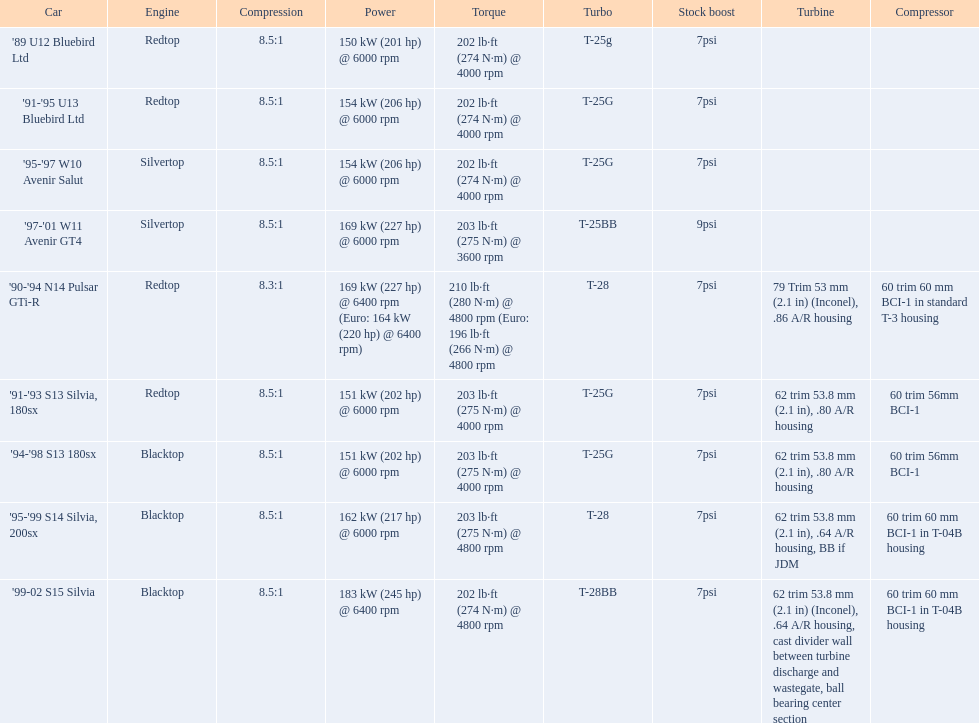What vehicles exist? '89 U12 Bluebird Ltd, 7psi, '91-'95 U13 Bluebird Ltd, 7psi, '95-'97 W10 Avenir Salut, 7psi, '97-'01 W11 Avenir GT4, 9psi, '90-'94 N14 Pulsar GTi-R, 7psi, '91-'93 S13 Silvia, 180sx, 7psi, '94-'98 S13 180sx, 7psi, '95-'99 S14 Silvia, 200sx, 7psi, '99-02 S15 Silvia, 7psi. Which standard boost surpasses 7psi? '97-'01 W11 Avenir GT4, 9psi. What automobile is it? '97-'01 W11 Avenir GT4. 